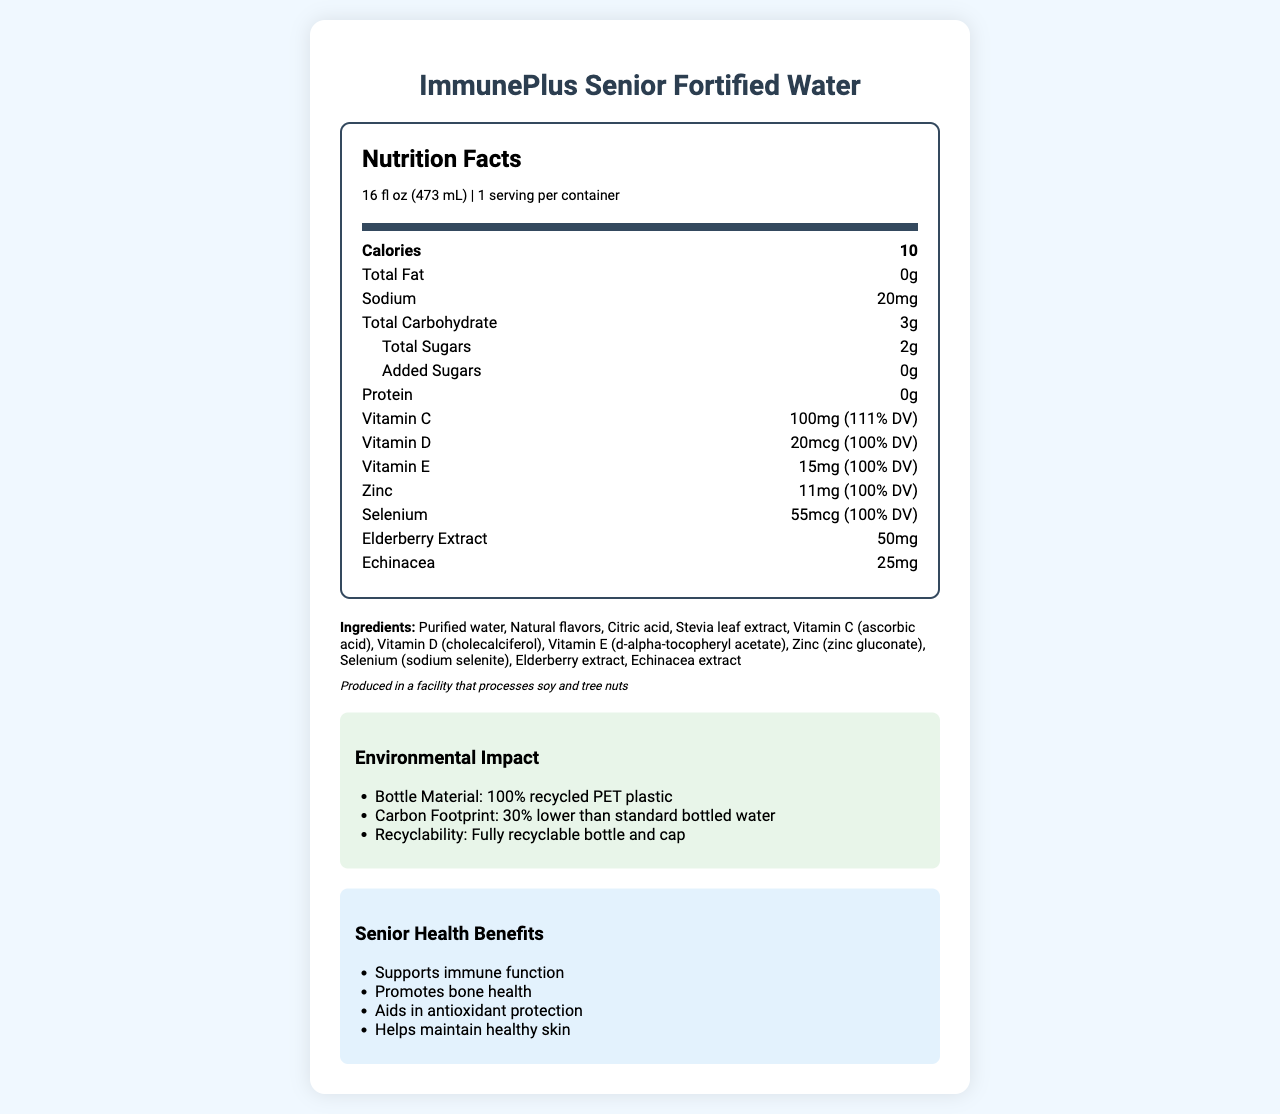what is the serving size? The serving size is stated right next to the product name under "Nutrition Facts."
Answer: 16 fl oz (473 mL) how many calories are in one serving? The number of calories per serving is listed right near the top of the Nutrition Facts section.
Answer: 10 how much sodium does one serving contain? The sodium content per serving is listed under the nutrient details.
Answer: 20mg how many grams of total carbohydrates are in one serving? The total carbohydrate content per serving is explicitly stated in the list of nutrients.
Answer: 3g what are the first three ingredients listed? The ingredients are listed in the document, and the first three are Purified water, Natural flavors, and Citric acid.
Answer: Purified water, Natural flavors, Citric acid what is the percentage of daily value for Vitamin C in this product? The percentage of daily value for Vitamin C is listed next to its nutritional information.
Answer: 111% list two minerals present in the beverage and their amounts. The presence and amount of Zinc and Selenium are indicated in the nutrient details.
Answer: Zinc: 11mg, Selenium: 55mcg which of these ingredients is not in the product? A. Stevia leaf extract B. Artificial sweeteners C. Citric acid D. Echinacea extract The ingredient list includes Stevia leaf extract, Citric acid, and Echinacea extract, but not artificial sweeteners.
Answer: B in which type of facility is this beverage produced? A. A dairy plant B. A facility that processes soy and tree nuts C. A facility that processes gluten products D. An organic food facility The allergen info states that it is produced in a facility that processes soy and tree nuts.
Answer: B is this bottle recyclable? The Environmental Impact section states that the bottle and cap are fully recyclable.
Answer: Yes how does the manufacturing process reduce carbon footprint compared to standard bottled water? The Environmental Impact section mentions that the product's carbon footprint is 30% lower than that of standard bottled water.
Answer: 30% lower carbon footprint how much elderberry extract is in each serving? The amount of elderberry extract per serving is listed under the nutrient details.
Answer: 50mg what is one of the benefits of this beverage for seniors? The document lists several senior health benefits, including supporting immune function.
Answer: Supports immune function which vitamins in this drink meet 100% daily value? The percentages next to Vitamin D and Vitamin E indicate they both meet 100% DV.
Answer: Vitamin D, Vitamin E what is the source of the water used in this product? The manufacturing process details mention that the water is sourced from local spring water.
Answer: Local spring water does the nutritional label mention calorie contribution from fat? The document shows that the total fat per serving is 0g, hence there is no calorie contribution from fat.
Answer: No describe the main idea of the document. The document provides detailed nutritional facts, lists the ingredients, explains the health benefits for seniors, and outlines the environmental sustainability initiatives related to the product.
Answer: A comprehensive overview of ImmunePlus Senior Fortified Water, highlighting its nutritional content, senior health benefits, environmental impact from sustainable packaging, and manufacturing processes. what is the exact energy usage value in the manufacturing process? The document mentions that the product is produced using 50% renewable energy, but does not provide exact energy usage values.
Answer: Not enough information 